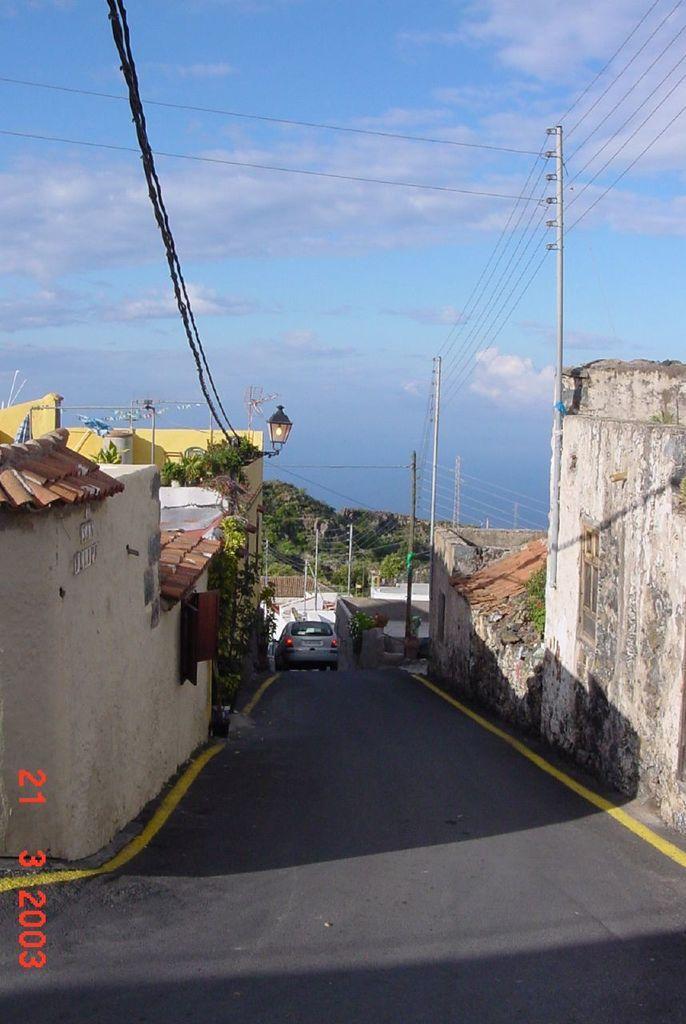Could you give a brief overview of what you see in this image? In this picture we can see the vehicle is moving on the road, beside we can see some houses. 